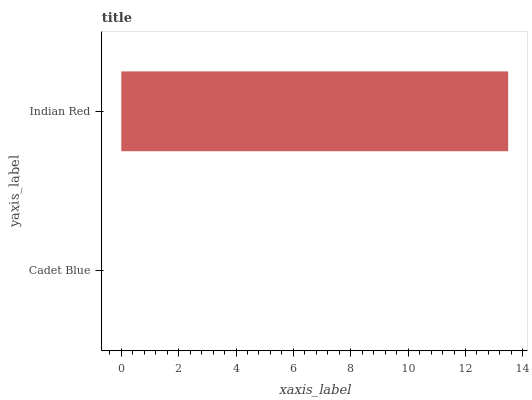Is Cadet Blue the minimum?
Answer yes or no. Yes. Is Indian Red the maximum?
Answer yes or no. Yes. Is Indian Red the minimum?
Answer yes or no. No. Is Indian Red greater than Cadet Blue?
Answer yes or no. Yes. Is Cadet Blue less than Indian Red?
Answer yes or no. Yes. Is Cadet Blue greater than Indian Red?
Answer yes or no. No. Is Indian Red less than Cadet Blue?
Answer yes or no. No. Is Indian Red the high median?
Answer yes or no. Yes. Is Cadet Blue the low median?
Answer yes or no. Yes. Is Cadet Blue the high median?
Answer yes or no. No. Is Indian Red the low median?
Answer yes or no. No. 